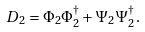<formula> <loc_0><loc_0><loc_500><loc_500>D _ { 2 } = \Phi _ { 2 } \Phi _ { 2 } ^ { \dagger } + \Psi _ { 2 } \Psi _ { 2 } ^ { \dagger } .</formula> 